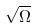Convert formula to latex. <formula><loc_0><loc_0><loc_500><loc_500>\sqrt { \Omega }</formula> 